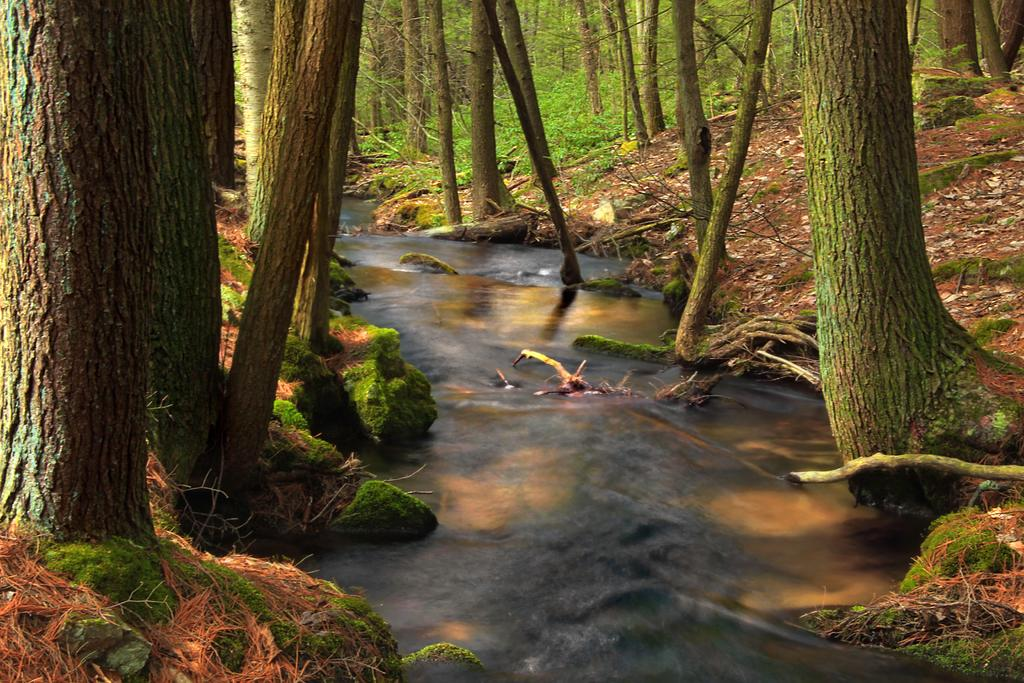What is the main feature in the center of the image? There is water in the center of the image. What can be seen on the left side of the image? There are trees on the left side of the image. What can be seen on the right side of the image? There are trees on the right side of the image. What type of vegetation is present in the image? There are plants in the image. What is visible beneath the water and trees? The ground is visible in the image. What additional detail can be observed on the ground? Dry leaves are present in the image. What type of screw can be seen in the image? There is no screw present in the image. Is there a farmer working in the image? There is no farmer present in the image. 